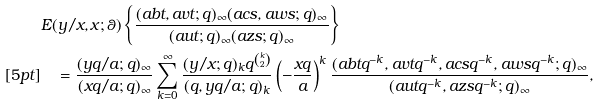<formula> <loc_0><loc_0><loc_500><loc_500>& E ( y / x , x ; \theta ) \left \{ \frac { ( a b t , a v t ; q ) _ { \infty } ( a c s , a w s ; q ) _ { \infty } } { ( a u t ; q ) _ { \infty } ( a z s ; q ) _ { \infty } } \right \} \\ [ 5 p t ] & \quad = \frac { ( y q / a ; q ) _ { \infty } } { ( x q / a ; q ) _ { \infty } } \sum _ { k = 0 } ^ { \infty } \frac { ( y / x ; q ) _ { k } q ^ { k \choose 2 } } { ( q , y q / a ; q ) _ { k } } \left ( - \frac { x q } { a } \right ) ^ { k } \frac { ( a b t q ^ { - k } , a v t q ^ { - k } , a c s q ^ { - k } , a w s q ^ { - k } ; q ) _ { \infty } } { ( a u t q ^ { - k } , a z s q ^ { - k } ; q ) _ { \infty } } ,</formula> 